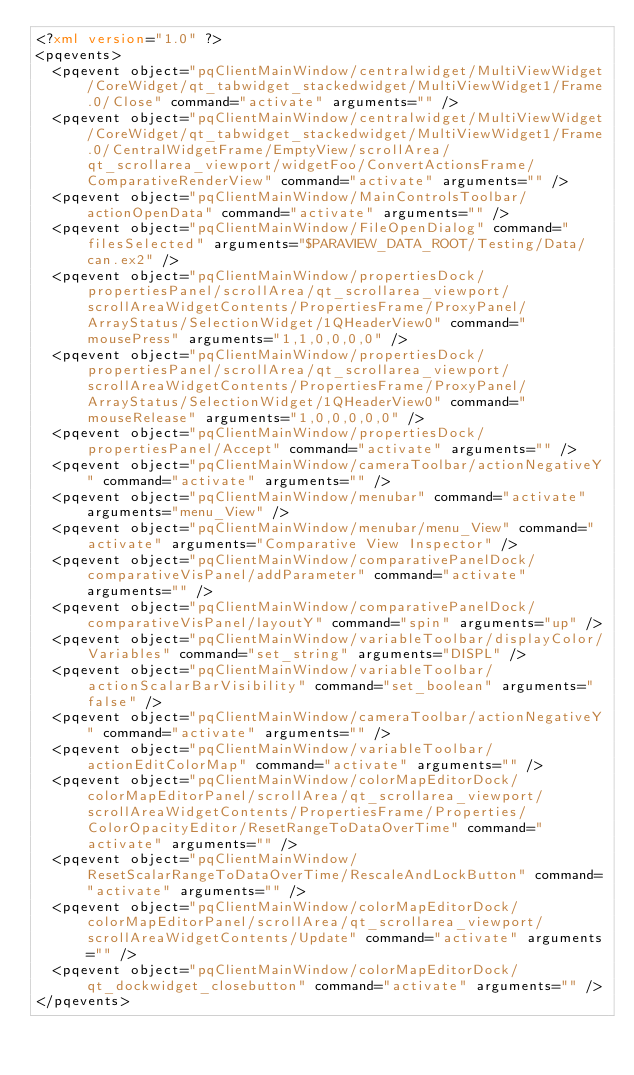Convert code to text. <code><loc_0><loc_0><loc_500><loc_500><_XML_><?xml version="1.0" ?>
<pqevents>
  <pqevent object="pqClientMainWindow/centralwidget/MultiViewWidget/CoreWidget/qt_tabwidget_stackedwidget/MultiViewWidget1/Frame.0/Close" command="activate" arguments="" />
  <pqevent object="pqClientMainWindow/centralwidget/MultiViewWidget/CoreWidget/qt_tabwidget_stackedwidget/MultiViewWidget1/Frame.0/CentralWidgetFrame/EmptyView/scrollArea/qt_scrollarea_viewport/widgetFoo/ConvertActionsFrame/ComparativeRenderView" command="activate" arguments="" />
  <pqevent object="pqClientMainWindow/MainControlsToolbar/actionOpenData" command="activate" arguments="" />
  <pqevent object="pqClientMainWindow/FileOpenDialog" command="filesSelected" arguments="$PARAVIEW_DATA_ROOT/Testing/Data/can.ex2" />
  <pqevent object="pqClientMainWindow/propertiesDock/propertiesPanel/scrollArea/qt_scrollarea_viewport/scrollAreaWidgetContents/PropertiesFrame/ProxyPanel/ArrayStatus/SelectionWidget/1QHeaderView0" command="mousePress" arguments="1,1,0,0,0,0" />
  <pqevent object="pqClientMainWindow/propertiesDock/propertiesPanel/scrollArea/qt_scrollarea_viewport/scrollAreaWidgetContents/PropertiesFrame/ProxyPanel/ArrayStatus/SelectionWidget/1QHeaderView0" command="mouseRelease" arguments="1,0,0,0,0,0" />
  <pqevent object="pqClientMainWindow/propertiesDock/propertiesPanel/Accept" command="activate" arguments="" />
  <pqevent object="pqClientMainWindow/cameraToolbar/actionNegativeY" command="activate" arguments="" />
  <pqevent object="pqClientMainWindow/menubar" command="activate" arguments="menu_View" />
  <pqevent object="pqClientMainWindow/menubar/menu_View" command="activate" arguments="Comparative View Inspector" />
  <pqevent object="pqClientMainWindow/comparativePanelDock/comparativeVisPanel/addParameter" command="activate" arguments="" />
  <pqevent object="pqClientMainWindow/comparativePanelDock/comparativeVisPanel/layoutY" command="spin" arguments="up" />
  <pqevent object="pqClientMainWindow/variableToolbar/displayColor/Variables" command="set_string" arguments="DISPL" />
  <pqevent object="pqClientMainWindow/variableToolbar/actionScalarBarVisibility" command="set_boolean" arguments="false" />
  <pqevent object="pqClientMainWindow/cameraToolbar/actionNegativeY" command="activate" arguments="" />
  <pqevent object="pqClientMainWindow/variableToolbar/actionEditColorMap" command="activate" arguments="" />
  <pqevent object="pqClientMainWindow/colorMapEditorDock/colorMapEditorPanel/scrollArea/qt_scrollarea_viewport/scrollAreaWidgetContents/PropertiesFrame/Properties/ColorOpacityEditor/ResetRangeToDataOverTime" command="activate" arguments="" />
  <pqevent object="pqClientMainWindow/ResetScalarRangeToDataOverTime/RescaleAndLockButton" command="activate" arguments="" />
  <pqevent object="pqClientMainWindow/colorMapEditorDock/colorMapEditorPanel/scrollArea/qt_scrollarea_viewport/scrollAreaWidgetContents/Update" command="activate" arguments="" />
  <pqevent object="pqClientMainWindow/colorMapEditorDock/qt_dockwidget_closebutton" command="activate" arguments="" />
</pqevents>
</code> 